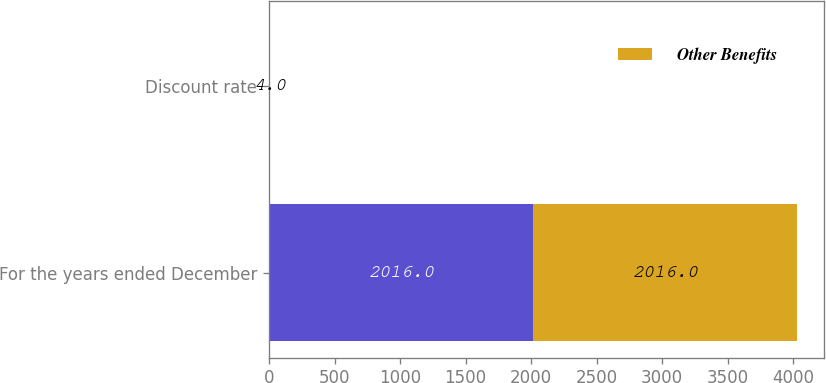<chart> <loc_0><loc_0><loc_500><loc_500><stacked_bar_chart><ecel><fcel>For the years ended December<fcel>Discount rate<nl><fcel>nan<fcel>2016<fcel>4<nl><fcel>Other Benefits<fcel>2016<fcel>4<nl></chart> 